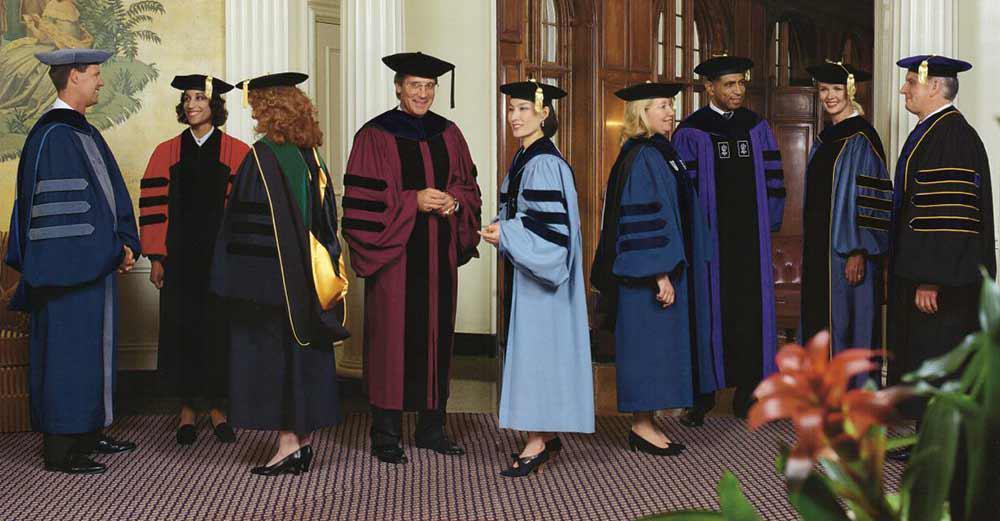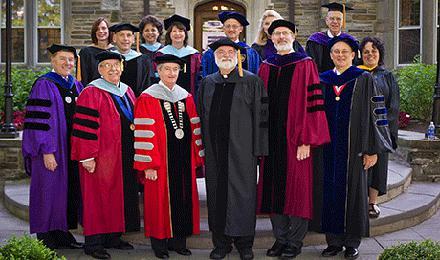The first image is the image on the left, the second image is the image on the right. Analyze the images presented: Is the assertion "There is at least one graduate wearing a green robe in the image on the left" valid? Answer yes or no. No. 